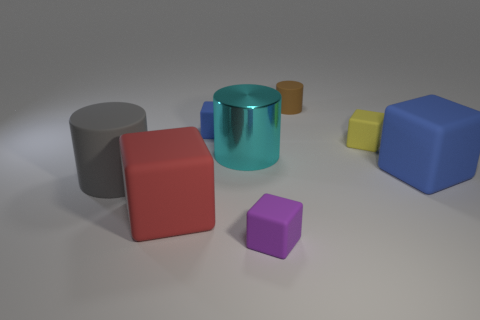How many blue matte cubes are there?
Provide a succinct answer. 2. Is the material of the small object that is on the right side of the brown cylinder the same as the large object in front of the large gray cylinder?
Provide a short and direct response. Yes. What is the size of the yellow cube that is made of the same material as the big gray cylinder?
Your answer should be compact. Small. There is a large matte object in front of the big gray rubber cylinder; what is its shape?
Give a very brief answer. Cube. Does the large matte block on the left side of the yellow block have the same color as the rubber cylinder that is on the right side of the large gray cylinder?
Offer a terse response. No. Are any gray objects visible?
Offer a very short reply. Yes. There is a brown object that is behind the big matte thing behind the gray thing that is on the left side of the purple rubber object; what is its shape?
Your answer should be very brief. Cylinder. There is a cyan thing; how many large cyan shiny cylinders are right of it?
Your answer should be very brief. 0. Are the blue cube to the right of the purple block and the small blue block made of the same material?
Offer a very short reply. Yes. How many other things are the same shape as the big gray rubber object?
Provide a succinct answer. 2. 